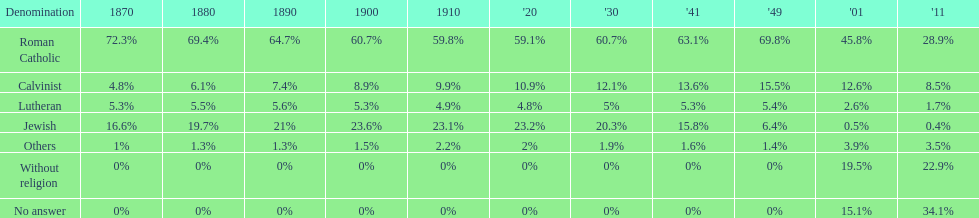What is the total percentage of people who identified as religious in 2011? 43%. 